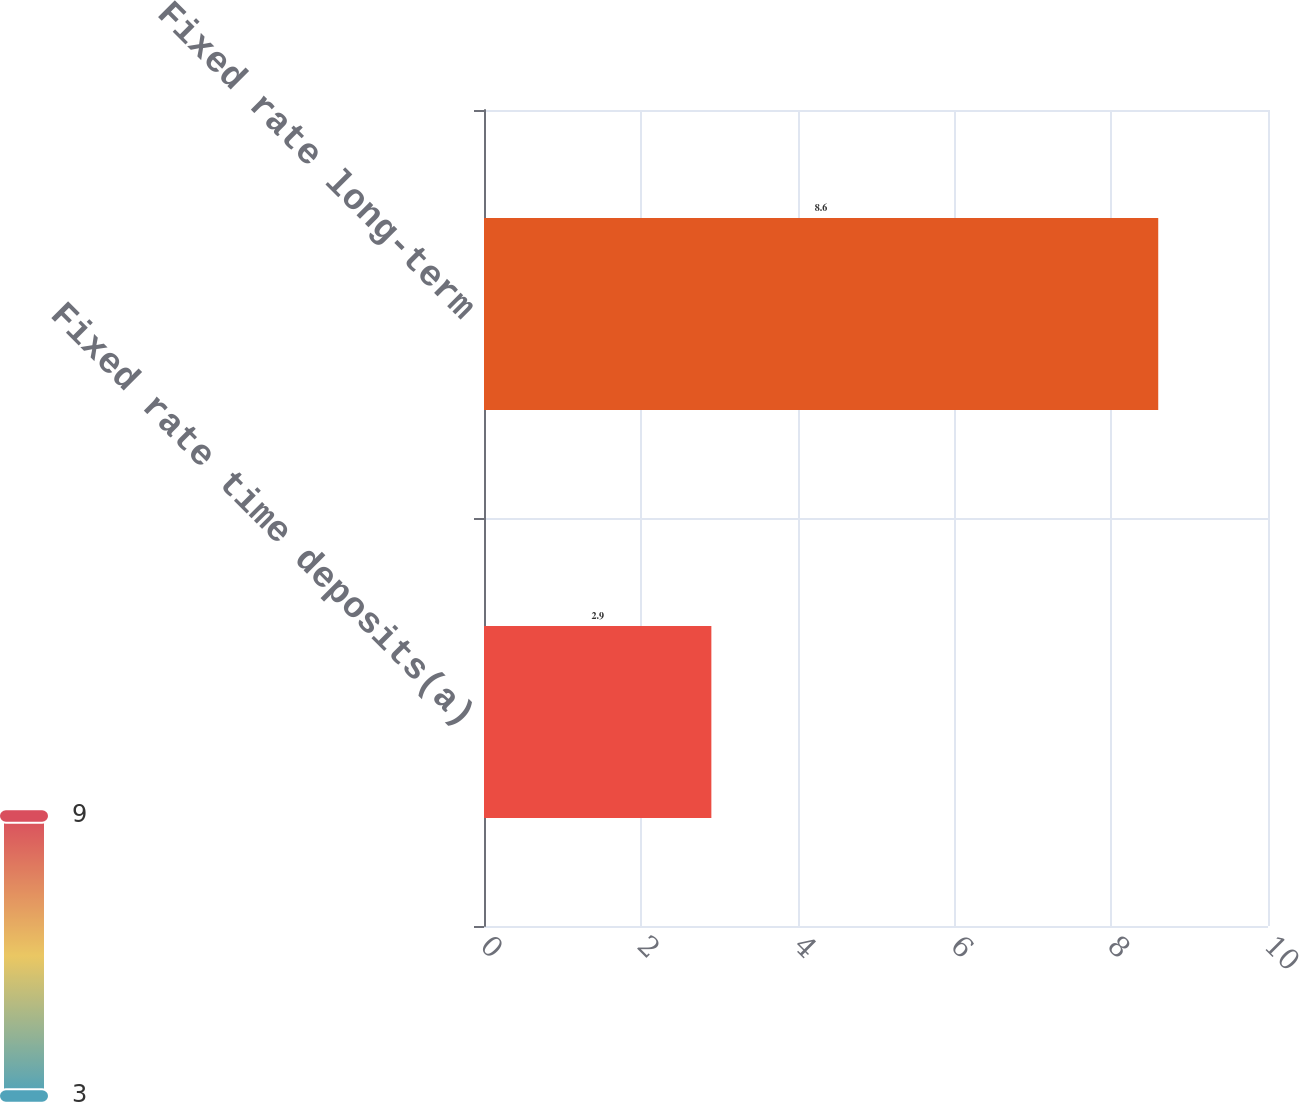Convert chart. <chart><loc_0><loc_0><loc_500><loc_500><bar_chart><fcel>Fixed rate time deposits(a)<fcel>Fixed rate long-term<nl><fcel>2.9<fcel>8.6<nl></chart> 